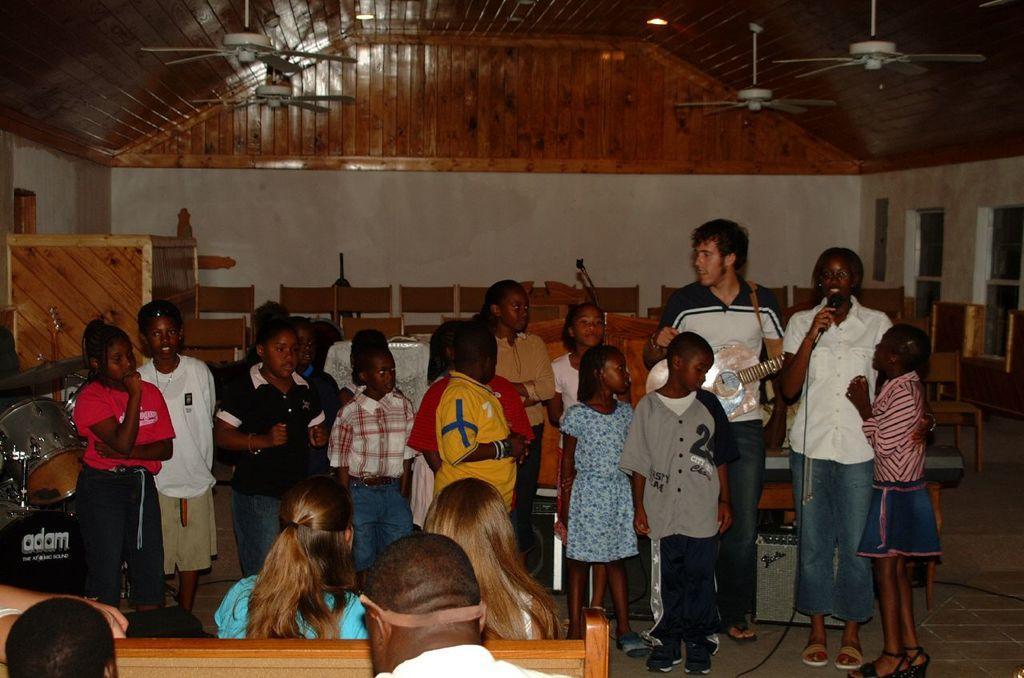Could you give a brief overview of what you see in this image? This is an inside view picture. Here we can see few benches benches and few persons are sitting on it. This is a floor. These few persons standing and singing. These are the drums. These are the fans over a ceiling. We can see a wall on the background. these are the windows at the right side of the picture. 